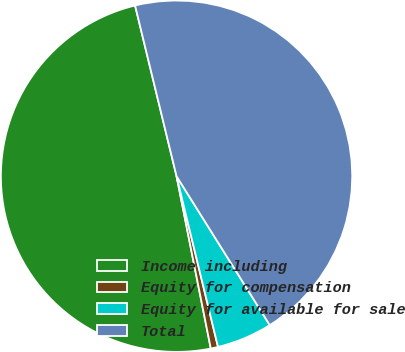<chart> <loc_0><loc_0><loc_500><loc_500><pie_chart><fcel>Income including<fcel>Equity for compensation<fcel>Equity for available for sale<fcel>Total<nl><fcel>49.33%<fcel>0.67%<fcel>5.11%<fcel>44.89%<nl></chart> 